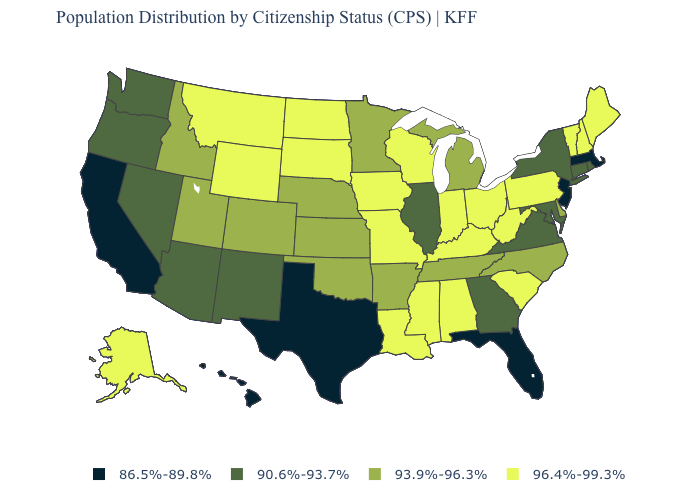What is the value of Kansas?
Short answer required. 93.9%-96.3%. Does the map have missing data?
Quick response, please. No. How many symbols are there in the legend?
Answer briefly. 4. Name the states that have a value in the range 90.6%-93.7%?
Quick response, please. Arizona, Connecticut, Georgia, Illinois, Maryland, Nevada, New Mexico, New York, Oregon, Rhode Island, Virginia, Washington. Does Indiana have the same value as New Jersey?
Answer briefly. No. What is the highest value in the USA?
Answer briefly. 96.4%-99.3%. What is the value of Arizona?
Write a very short answer. 90.6%-93.7%. What is the value of North Carolina?
Answer briefly. 93.9%-96.3%. What is the value of Georgia?
Quick response, please. 90.6%-93.7%. Is the legend a continuous bar?
Write a very short answer. No. Does Missouri have a higher value than Ohio?
Give a very brief answer. No. Which states have the lowest value in the West?
Quick response, please. California, Hawaii. What is the value of New York?
Quick response, please. 90.6%-93.7%. Name the states that have a value in the range 90.6%-93.7%?
Keep it brief. Arizona, Connecticut, Georgia, Illinois, Maryland, Nevada, New Mexico, New York, Oregon, Rhode Island, Virginia, Washington. What is the highest value in the USA?
Keep it brief. 96.4%-99.3%. 